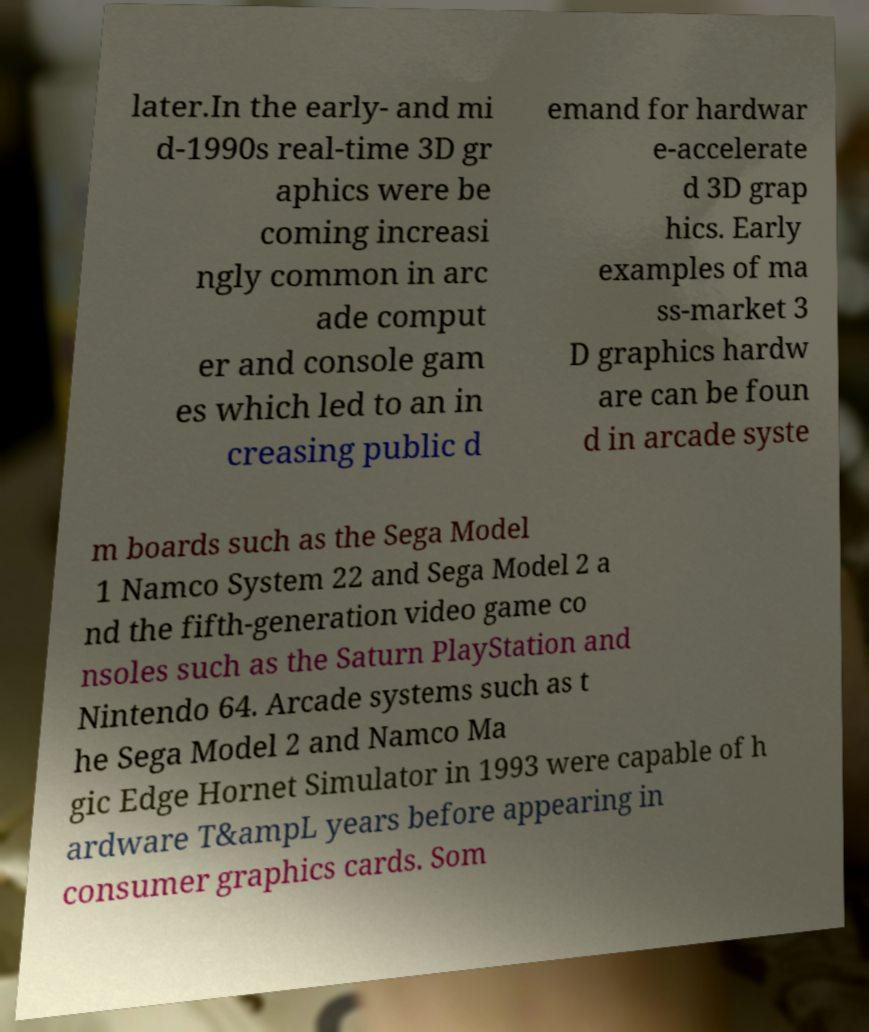Could you extract and type out the text from this image? later.In the early- and mi d-1990s real-time 3D gr aphics were be coming increasi ngly common in arc ade comput er and console gam es which led to an in creasing public d emand for hardwar e-accelerate d 3D grap hics. Early examples of ma ss-market 3 D graphics hardw are can be foun d in arcade syste m boards such as the Sega Model 1 Namco System 22 and Sega Model 2 a nd the fifth-generation video game co nsoles such as the Saturn PlayStation and Nintendo 64. Arcade systems such as t he Sega Model 2 and Namco Ma gic Edge Hornet Simulator in 1993 were capable of h ardware T&ampL years before appearing in consumer graphics cards. Som 